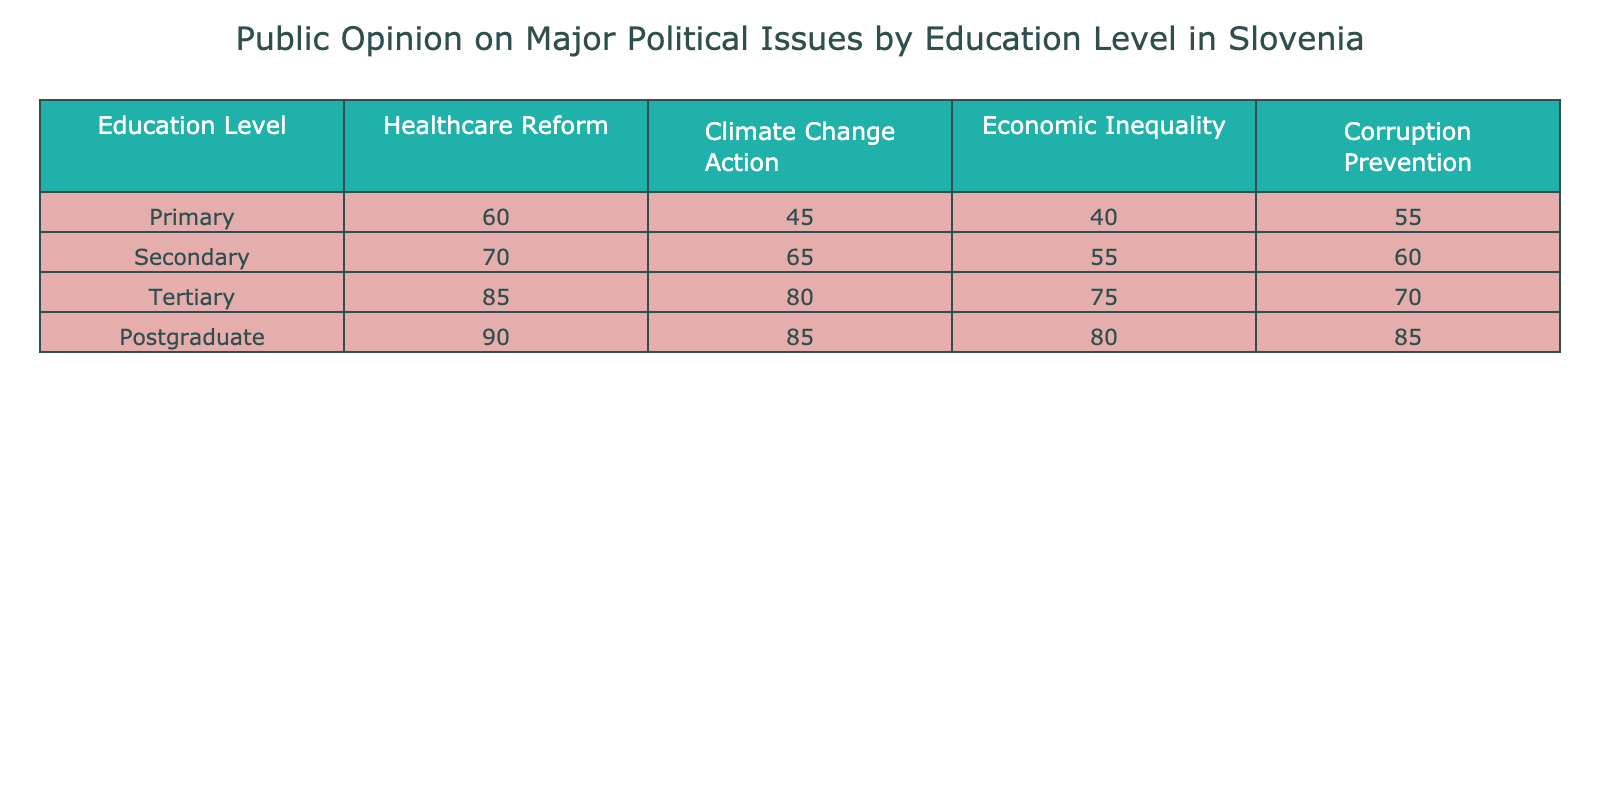What is the highest percentage support for Healthcare Reform? The highest percentage support for Healthcare Reform can be found by looking through the values under the Healthcare Reform column. The values are: 60, 70, 85, and 90. The maximum among these is 90, corresponding to Postgraduate education level.
Answer: 90 What is the percentage for Economic Inequality among those with Secondary education? To find the percentage for Economic Inequality among those with Secondary education, refer to the Economic Inequality column and locate the row for Secondary education, which is 55.
Answer: 55 Is the support for Corruption Prevention higher in Postgraduate education compared to Tertiary education? The support for Corruption Prevention for Postgraduate education is 85, and for Tertiary education, it is 70. Since 85 is greater than 70, the support for Corruption Prevention is indeed higher in Postgraduate education.
Answer: Yes What is the average percentage support for Climate Change Action across all education levels? To find the average, add all the Climate Change Action values: 45 (Primary) + 65 (Secondary) + 80 (Tertiary) + 85 (Postgraduate) = 275. Then, divide by the number of education levels, which is 4. Therefore, the average is 275/4 = 68.75.
Answer: 68.75 Which education level shows the least support for Healthcare Reform? The values for Healthcare Reform are 60, 70, 85, and 90. The least support is identified by the smallest value, which corresponds to Primary education at 60.
Answer: Primary What is the difference in percentage support for Climate Change Action between Postgraduate and Primary education? To calculate the difference, take the values for Postgraduate (85) and Primary (45) in the Climate Change Action column. The difference is 85 - 45 = 40.
Answer: 40 Which education level has the highest percentage for Economic Inequality? The values for Economic Inequality are 40 (Primary), 55 (Secondary), 75 (Tertiary), and 80 (Postgraduate). The highest percentage is 80, corresponding to Postgraduate education.
Answer: Postgraduate Does the data suggest that Tertiary education provides more support for Economic Inequality than Primary education? Tertiary education support for Economic Inequality is 75, while Primary education support is 40. Since 75 is greater than 40, it indicates that Tertiary education indeed provides more support.
Answer: Yes What percentage of individuals with Primary education think Climate Change action is important? From the table, the value in the Climate Change Action column for Primary education is 45.
Answer: 45 